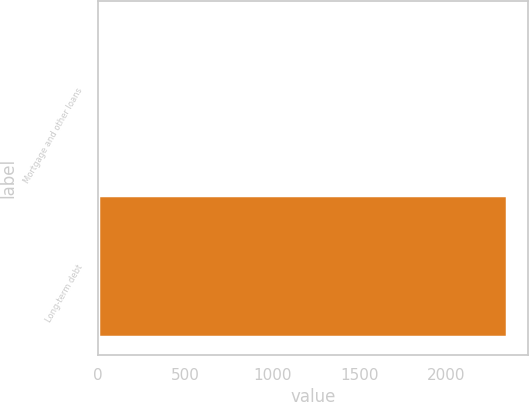Convert chart to OTSL. <chart><loc_0><loc_0><loc_500><loc_500><bar_chart><fcel>Mortgage and other loans<fcel>Long-term debt<nl><fcel>7<fcel>2350<nl></chart> 